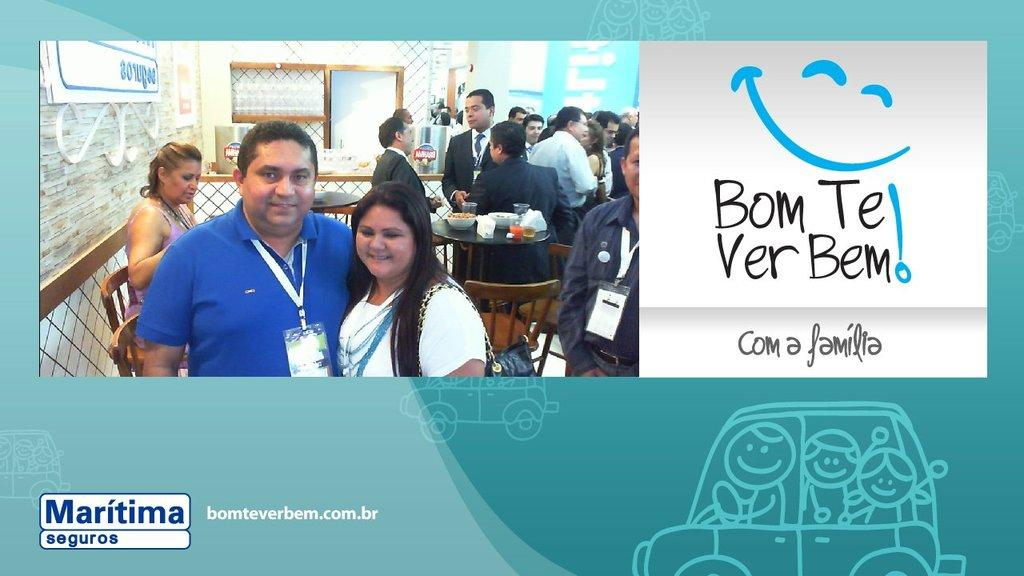What is featured on the poster in the image? The poster contains people and diagrams. Are there any structures or objects in the poster? Yes, there is a fence in the poster. Are there any other posters visible in the image? Yes, there are posters attached to the wall in the poster. What else can be seen in the poster? There is a window in the poster. What type of information is present in the image? There is text in the image. Can you tell me how many snakes are crawling out of the drawer in the image? There is no drawer or snake present in the image. 